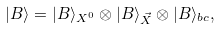<formula> <loc_0><loc_0><loc_500><loc_500>| B \rangle = | B \rangle _ { X ^ { 0 } } \otimes | B \rangle _ { \vec { X } } \otimes | B \rangle _ { b c } ,</formula> 